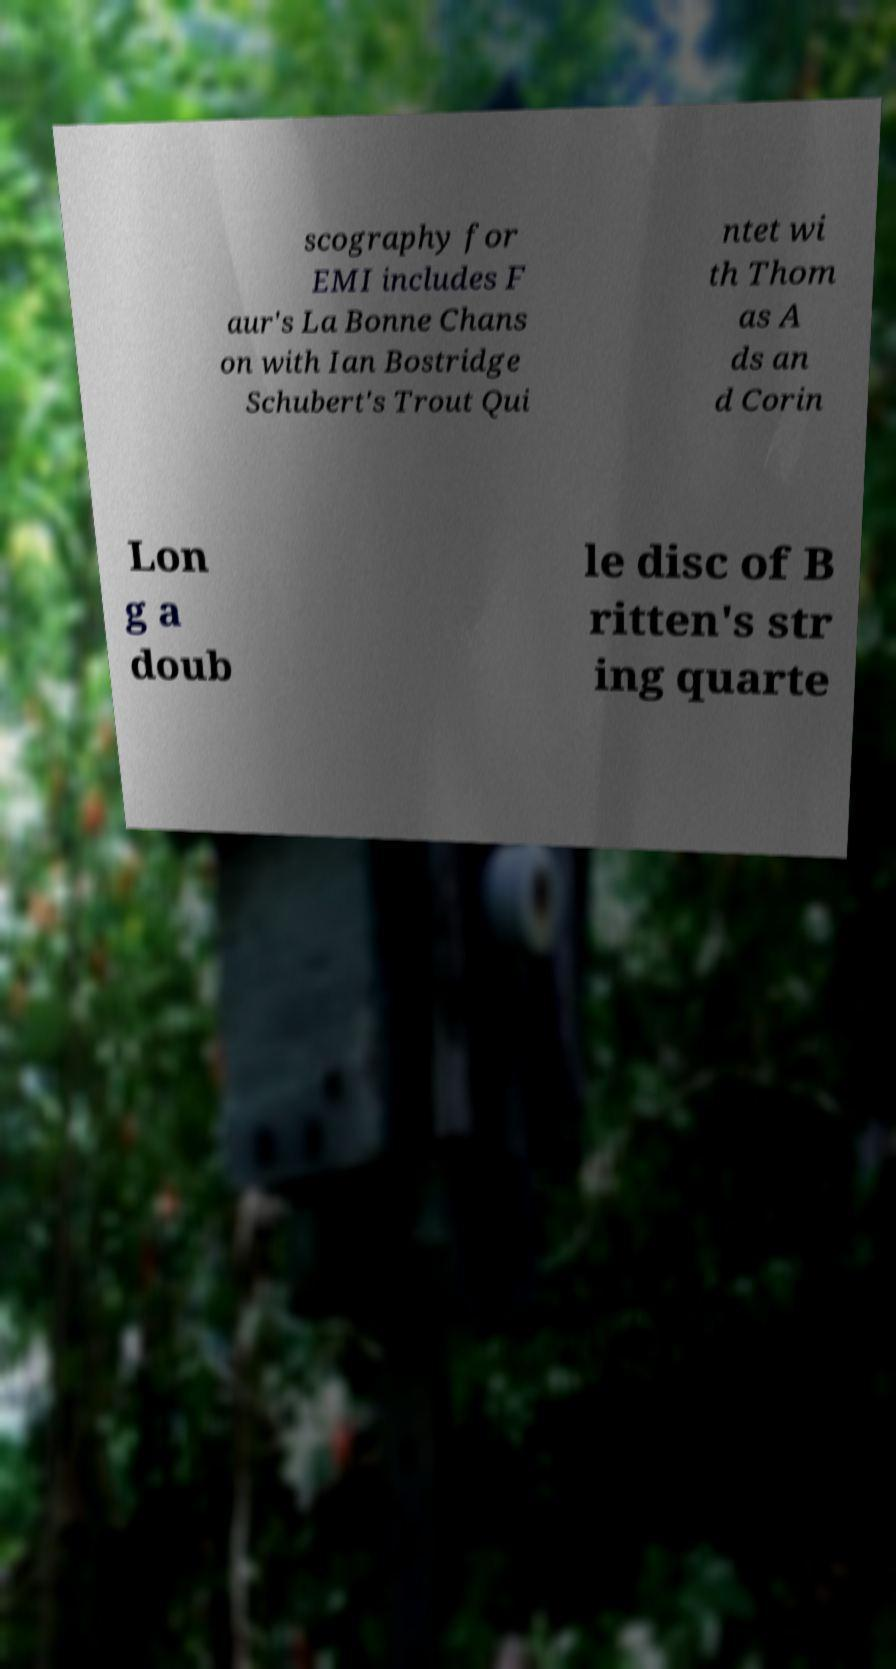Could you assist in decoding the text presented in this image and type it out clearly? scography for EMI includes F aur's La Bonne Chans on with Ian Bostridge Schubert's Trout Qui ntet wi th Thom as A ds an d Corin Lon g a doub le disc of B ritten's str ing quarte 